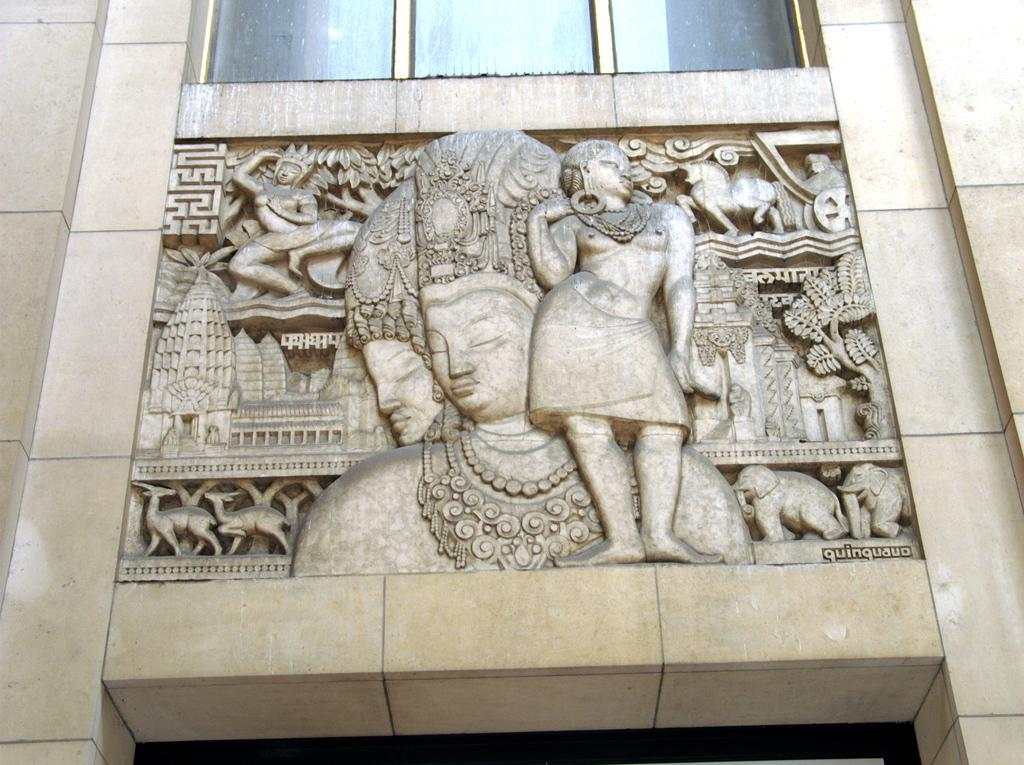What is the main subject of the image? There is a sculpture of people in the image. What else can be seen on the wall in the image? There are objects on the wall in the image. What type of structure is visible in the image? There is a wall visible in the image. What is visible at the top of the wall in the image? There are windows at the top of the image. How many bikes are parked near the sculpture in the image? There are no bikes present in the image. What type of brush is being used by the geese in the image? There are no geese or brushes present in the image. 